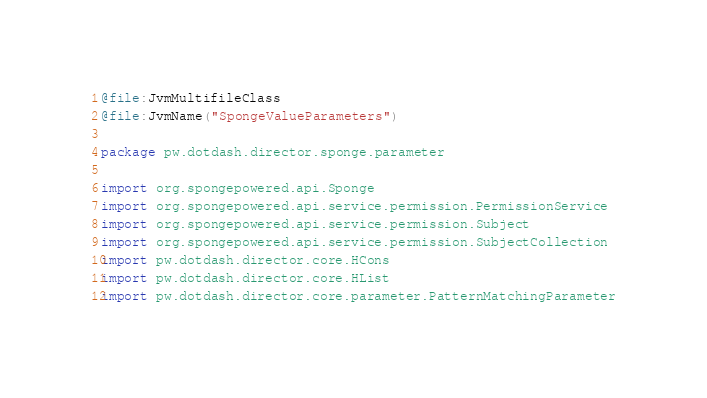<code> <loc_0><loc_0><loc_500><loc_500><_Kotlin_>@file:JvmMultifileClass
@file:JvmName("SpongeValueParameters")

package pw.dotdash.director.sponge.parameter

import org.spongepowered.api.Sponge
import org.spongepowered.api.service.permission.PermissionService
import org.spongepowered.api.service.permission.Subject
import org.spongepowered.api.service.permission.SubjectCollection
import pw.dotdash.director.core.HCons
import pw.dotdash.director.core.HList
import pw.dotdash.director.core.parameter.PatternMatchingParameter</code> 